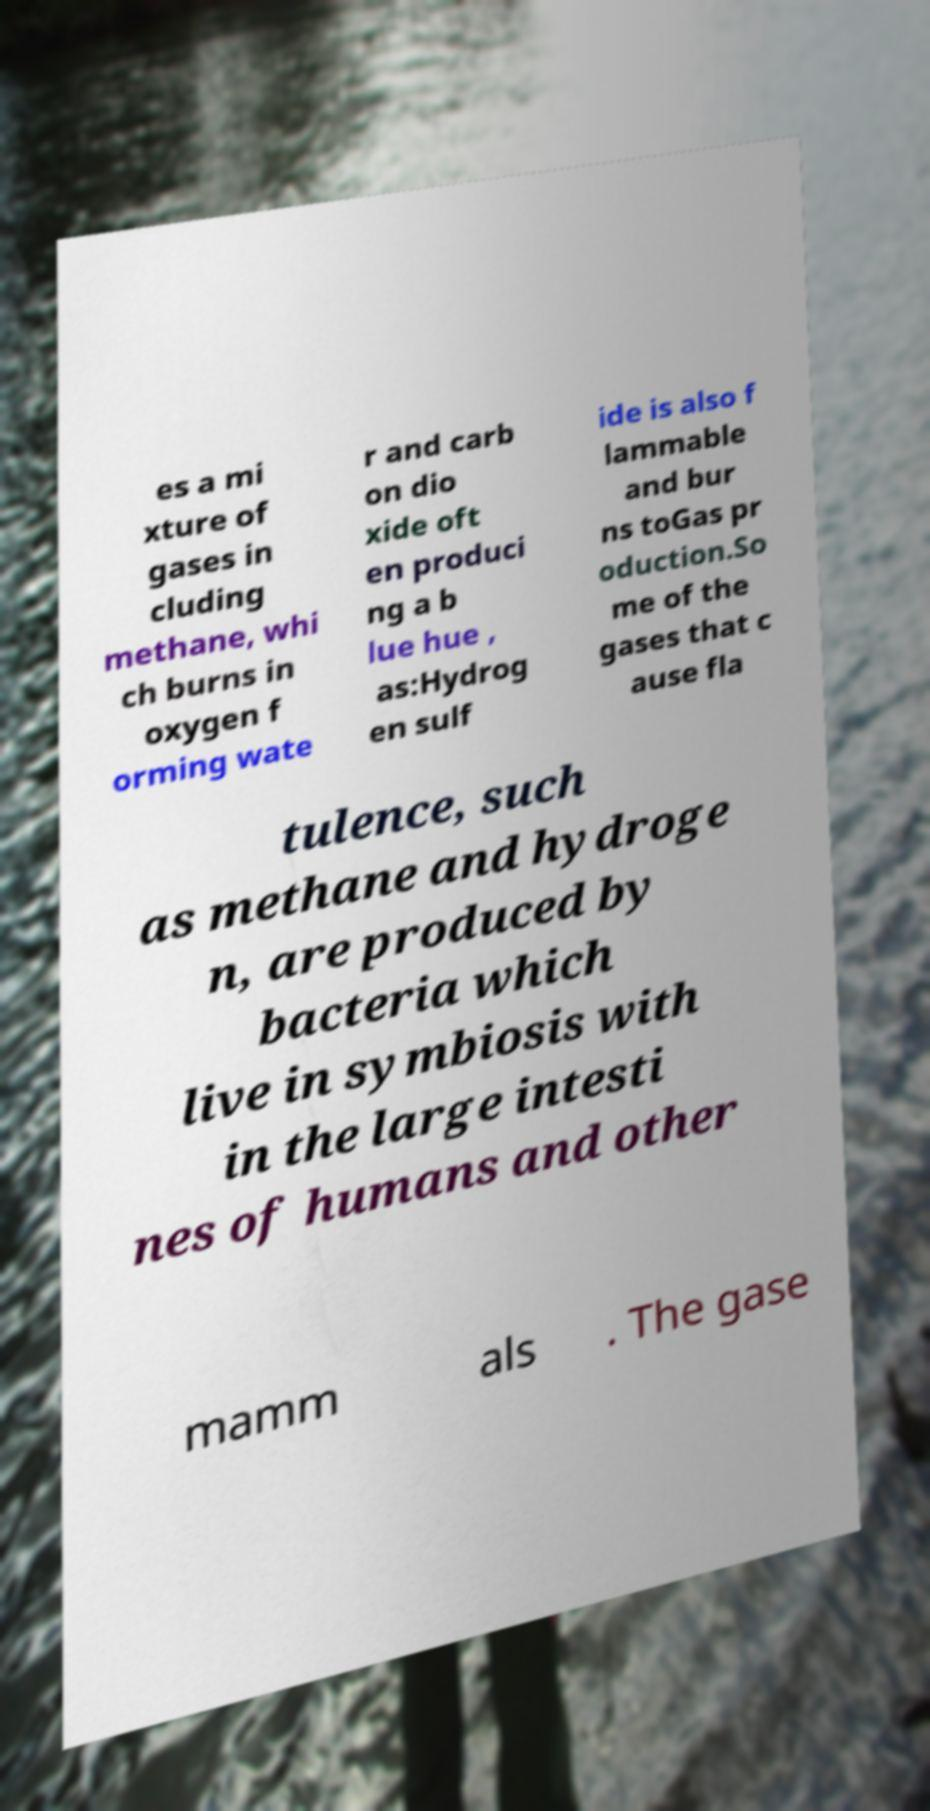There's text embedded in this image that I need extracted. Can you transcribe it verbatim? es a mi xture of gases in cluding methane, whi ch burns in oxygen f orming wate r and carb on dio xide oft en produci ng a b lue hue , as:Hydrog en sulf ide is also f lammable and bur ns toGas pr oduction.So me of the gases that c ause fla tulence, such as methane and hydroge n, are produced by bacteria which live in symbiosis with in the large intesti nes of humans and other mamm als . The gase 